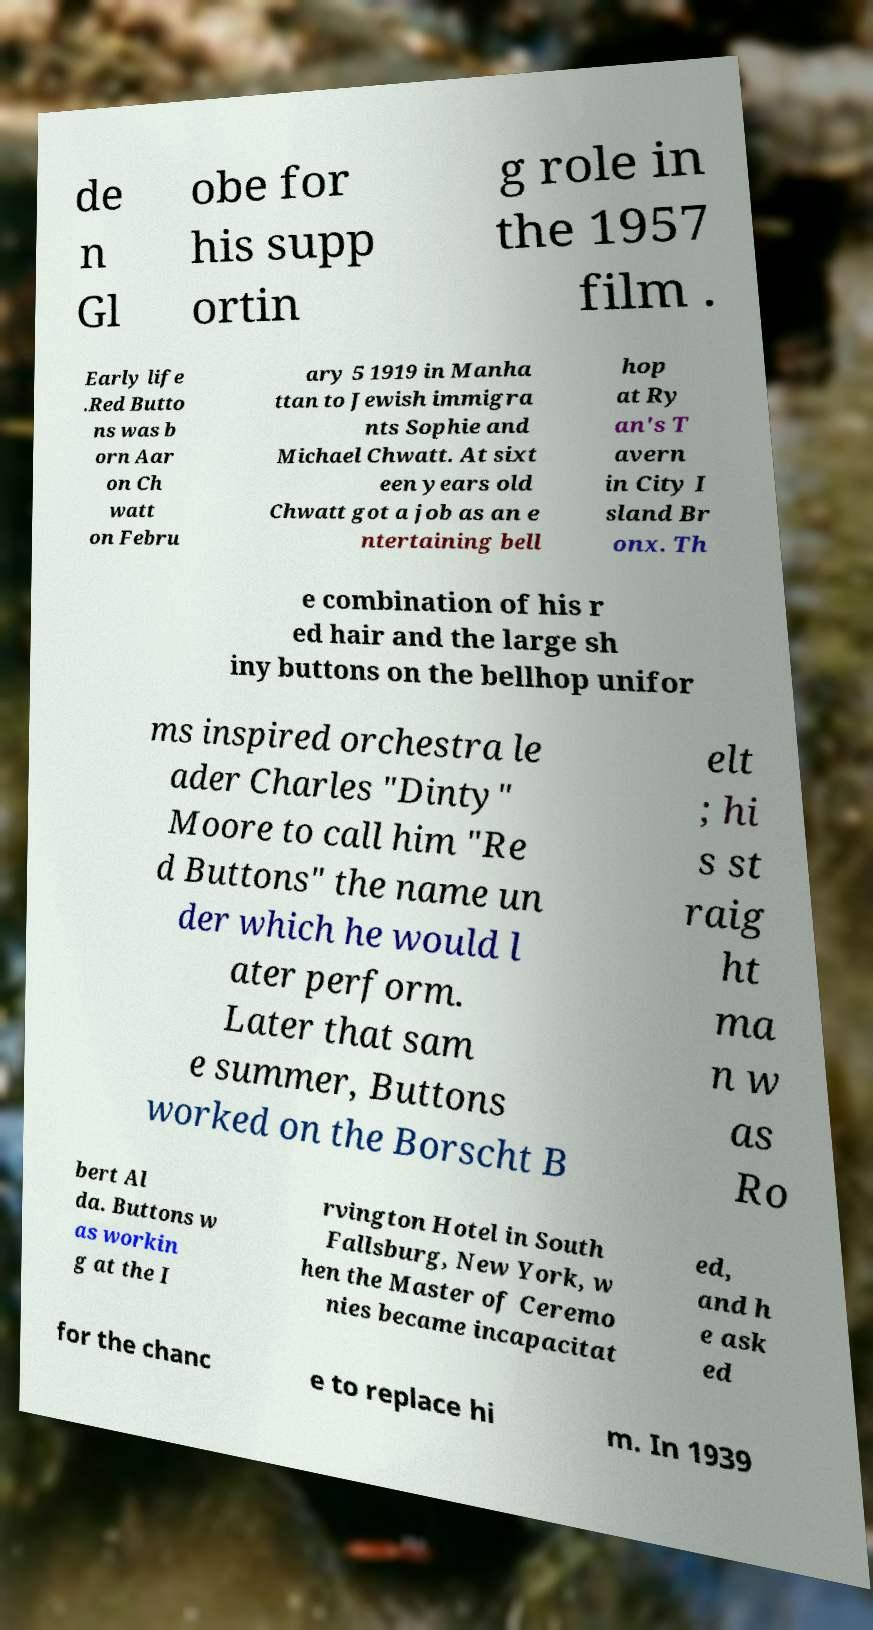Could you assist in decoding the text presented in this image and type it out clearly? de n Gl obe for his supp ortin g role in the 1957 film . Early life .Red Butto ns was b orn Aar on Ch watt on Febru ary 5 1919 in Manha ttan to Jewish immigra nts Sophie and Michael Chwatt. At sixt een years old Chwatt got a job as an e ntertaining bell hop at Ry an's T avern in City I sland Br onx. Th e combination of his r ed hair and the large sh iny buttons on the bellhop unifor ms inspired orchestra le ader Charles "Dinty" Moore to call him "Re d Buttons" the name un der which he would l ater perform. Later that sam e summer, Buttons worked on the Borscht B elt ; hi s st raig ht ma n w as Ro bert Al da. Buttons w as workin g at the I rvington Hotel in South Fallsburg, New York, w hen the Master of Ceremo nies became incapacitat ed, and h e ask ed for the chanc e to replace hi m. In 1939 